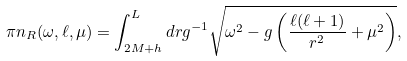<formula> <loc_0><loc_0><loc_500><loc_500>\pi n _ { R } ( \omega , \ell , \mu ) = \int _ { 2 M + h } ^ { L } d r g ^ { - 1 } \sqrt { \omega ^ { 2 } - g \left ( \frac { \ell ( \ell + 1 ) } { r ^ { 2 } } + \mu ^ { 2 } \right ) } ,</formula> 